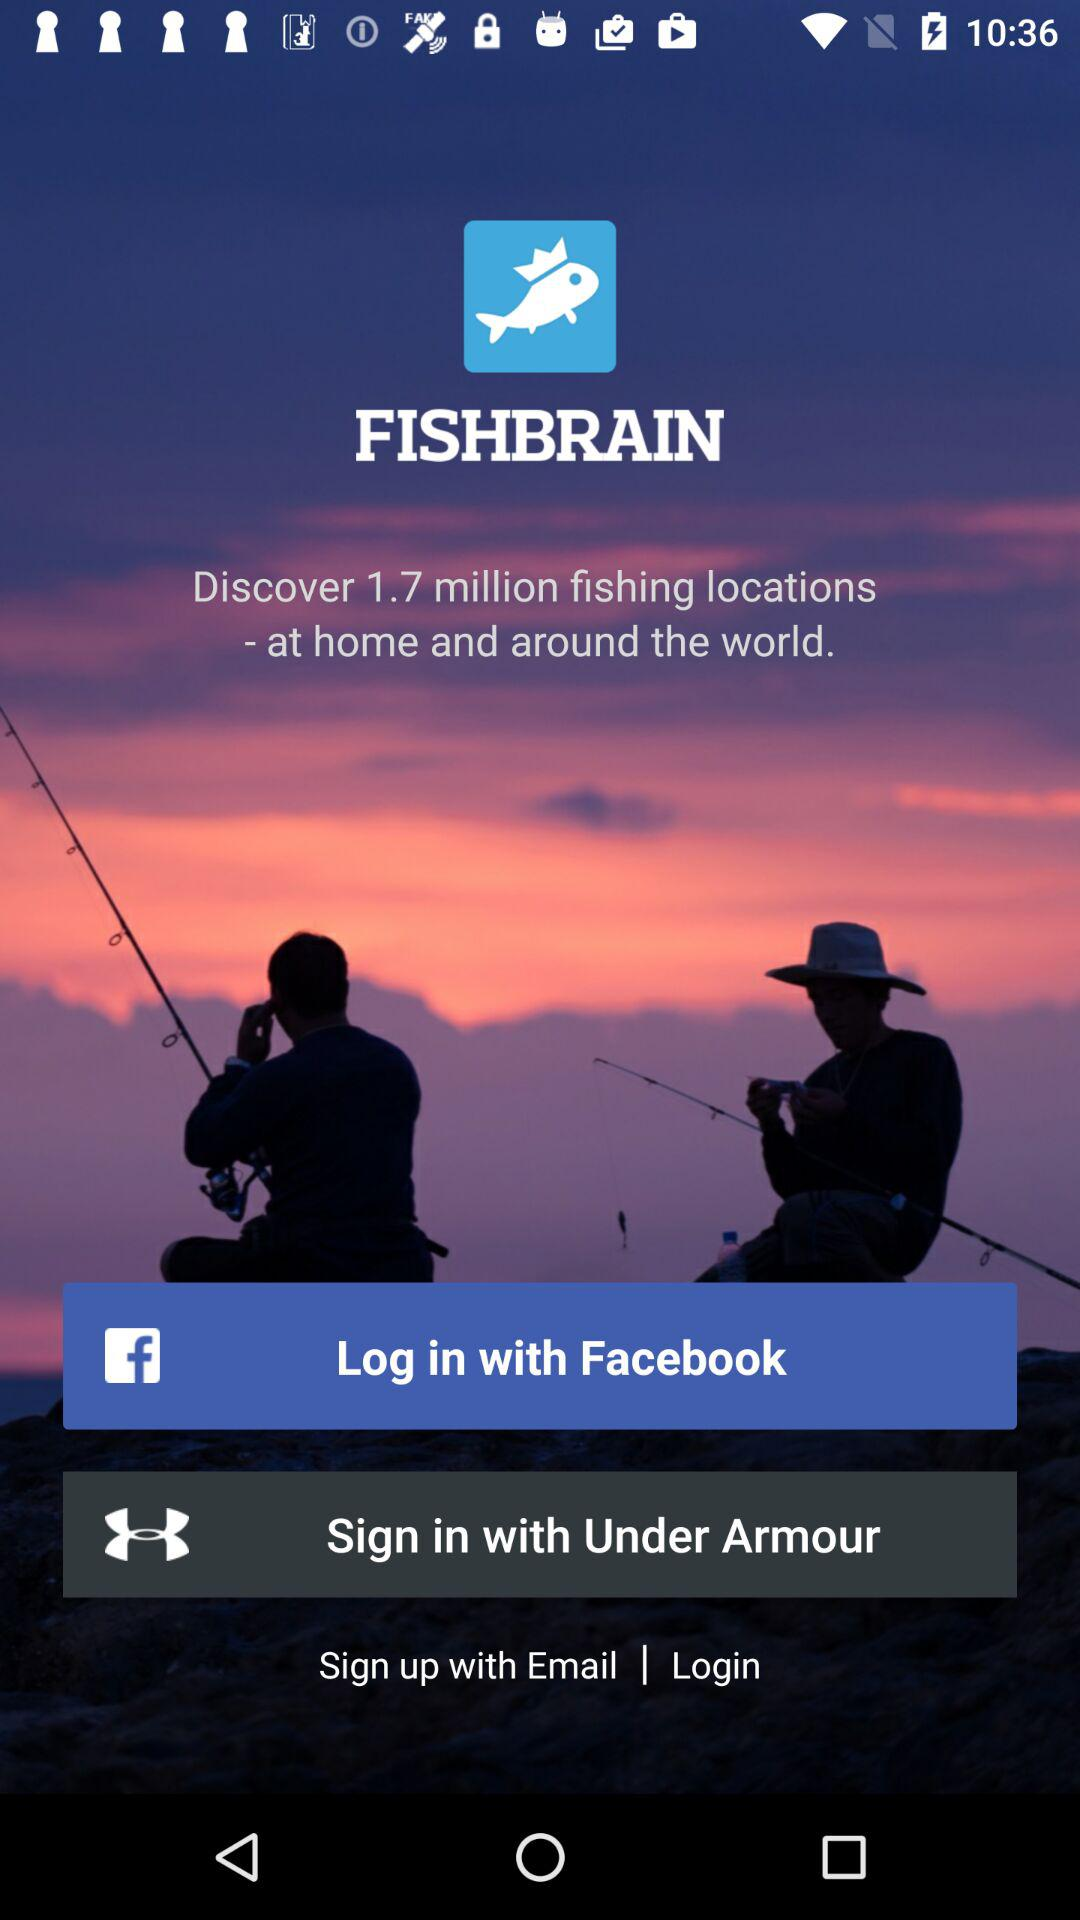Through what application can we log in? You can log in with "Facebook". 